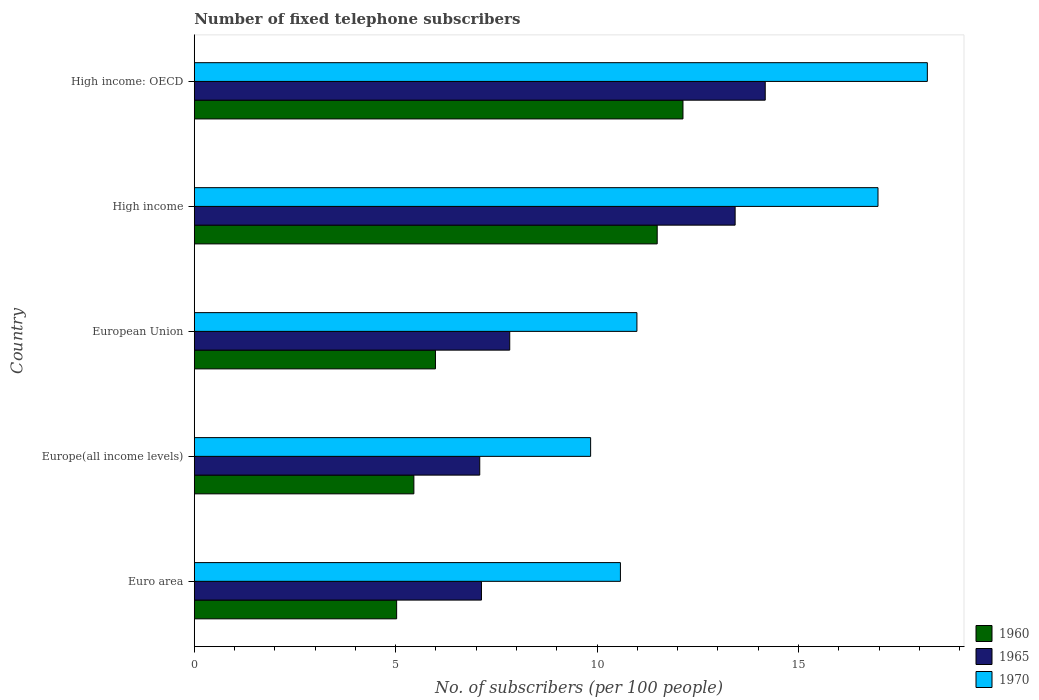How many different coloured bars are there?
Give a very brief answer. 3. How many groups of bars are there?
Your answer should be compact. 5. Are the number of bars per tick equal to the number of legend labels?
Offer a very short reply. Yes. What is the label of the 5th group of bars from the top?
Keep it short and to the point. Euro area. In how many cases, is the number of bars for a given country not equal to the number of legend labels?
Make the answer very short. 0. What is the number of fixed telephone subscribers in 1970 in European Union?
Offer a very short reply. 10.99. Across all countries, what is the maximum number of fixed telephone subscribers in 1970?
Give a very brief answer. 18.2. Across all countries, what is the minimum number of fixed telephone subscribers in 1960?
Your response must be concise. 5.02. In which country was the number of fixed telephone subscribers in 1965 maximum?
Offer a terse response. High income: OECD. In which country was the number of fixed telephone subscribers in 1970 minimum?
Give a very brief answer. Europe(all income levels). What is the total number of fixed telephone subscribers in 1970 in the graph?
Provide a succinct answer. 66.58. What is the difference between the number of fixed telephone subscribers in 1960 in Europe(all income levels) and that in High income?
Provide a short and direct response. -6.04. What is the difference between the number of fixed telephone subscribers in 1970 in European Union and the number of fixed telephone subscribers in 1965 in High income?
Your answer should be compact. -2.44. What is the average number of fixed telephone subscribers in 1965 per country?
Make the answer very short. 9.93. What is the difference between the number of fixed telephone subscribers in 1965 and number of fixed telephone subscribers in 1970 in High income?
Keep it short and to the point. -3.55. What is the ratio of the number of fixed telephone subscribers in 1970 in Euro area to that in High income: OECD?
Give a very brief answer. 0.58. What is the difference between the highest and the second highest number of fixed telephone subscribers in 1970?
Provide a succinct answer. 1.22. What is the difference between the highest and the lowest number of fixed telephone subscribers in 1960?
Your answer should be very brief. 7.11. What does the 3rd bar from the bottom in Euro area represents?
Your answer should be very brief. 1970. Is it the case that in every country, the sum of the number of fixed telephone subscribers in 1965 and number of fixed telephone subscribers in 1960 is greater than the number of fixed telephone subscribers in 1970?
Provide a short and direct response. Yes. How many bars are there?
Make the answer very short. 15. How many countries are there in the graph?
Provide a short and direct response. 5. Are the values on the major ticks of X-axis written in scientific E-notation?
Offer a very short reply. No. How many legend labels are there?
Your answer should be very brief. 3. What is the title of the graph?
Offer a very short reply. Number of fixed telephone subscribers. What is the label or title of the X-axis?
Your response must be concise. No. of subscribers (per 100 people). What is the No. of subscribers (per 100 people) in 1960 in Euro area?
Offer a very short reply. 5.02. What is the No. of subscribers (per 100 people) in 1965 in Euro area?
Your response must be concise. 7.13. What is the No. of subscribers (per 100 people) in 1970 in Euro area?
Provide a short and direct response. 10.58. What is the No. of subscribers (per 100 people) of 1960 in Europe(all income levels)?
Your answer should be compact. 5.45. What is the No. of subscribers (per 100 people) in 1965 in Europe(all income levels)?
Keep it short and to the point. 7.09. What is the No. of subscribers (per 100 people) of 1970 in Europe(all income levels)?
Your answer should be very brief. 9.84. What is the No. of subscribers (per 100 people) in 1960 in European Union?
Keep it short and to the point. 5.99. What is the No. of subscribers (per 100 people) of 1965 in European Union?
Keep it short and to the point. 7.83. What is the No. of subscribers (per 100 people) in 1970 in European Union?
Offer a very short reply. 10.99. What is the No. of subscribers (per 100 people) in 1960 in High income?
Offer a very short reply. 11.49. What is the No. of subscribers (per 100 people) of 1965 in High income?
Make the answer very short. 13.43. What is the No. of subscribers (per 100 people) in 1970 in High income?
Offer a terse response. 16.97. What is the No. of subscribers (per 100 people) of 1960 in High income: OECD?
Offer a very short reply. 12.13. What is the No. of subscribers (per 100 people) in 1965 in High income: OECD?
Provide a short and direct response. 14.17. What is the No. of subscribers (per 100 people) in 1970 in High income: OECD?
Your answer should be compact. 18.2. Across all countries, what is the maximum No. of subscribers (per 100 people) in 1960?
Keep it short and to the point. 12.13. Across all countries, what is the maximum No. of subscribers (per 100 people) in 1965?
Offer a terse response. 14.17. Across all countries, what is the maximum No. of subscribers (per 100 people) in 1970?
Give a very brief answer. 18.2. Across all countries, what is the minimum No. of subscribers (per 100 people) of 1960?
Your answer should be compact. 5.02. Across all countries, what is the minimum No. of subscribers (per 100 people) in 1965?
Make the answer very short. 7.09. Across all countries, what is the minimum No. of subscribers (per 100 people) of 1970?
Ensure brevity in your answer.  9.84. What is the total No. of subscribers (per 100 people) of 1960 in the graph?
Give a very brief answer. 40.08. What is the total No. of subscribers (per 100 people) of 1965 in the graph?
Offer a terse response. 49.65. What is the total No. of subscribers (per 100 people) of 1970 in the graph?
Your answer should be compact. 66.58. What is the difference between the No. of subscribers (per 100 people) of 1960 in Euro area and that in Europe(all income levels)?
Provide a succinct answer. -0.43. What is the difference between the No. of subscribers (per 100 people) in 1965 in Euro area and that in Europe(all income levels)?
Your response must be concise. 0.04. What is the difference between the No. of subscribers (per 100 people) in 1970 in Euro area and that in Europe(all income levels)?
Offer a very short reply. 0.74. What is the difference between the No. of subscribers (per 100 people) of 1960 in Euro area and that in European Union?
Your response must be concise. -0.96. What is the difference between the No. of subscribers (per 100 people) of 1965 in Euro area and that in European Union?
Give a very brief answer. -0.7. What is the difference between the No. of subscribers (per 100 people) of 1970 in Euro area and that in European Union?
Provide a short and direct response. -0.41. What is the difference between the No. of subscribers (per 100 people) in 1960 in Euro area and that in High income?
Ensure brevity in your answer.  -6.47. What is the difference between the No. of subscribers (per 100 people) of 1965 in Euro area and that in High income?
Ensure brevity in your answer.  -6.3. What is the difference between the No. of subscribers (per 100 people) of 1970 in Euro area and that in High income?
Provide a short and direct response. -6.39. What is the difference between the No. of subscribers (per 100 people) in 1960 in Euro area and that in High income: OECD?
Provide a short and direct response. -7.11. What is the difference between the No. of subscribers (per 100 people) of 1965 in Euro area and that in High income: OECD?
Ensure brevity in your answer.  -7.04. What is the difference between the No. of subscribers (per 100 people) in 1970 in Euro area and that in High income: OECD?
Offer a very short reply. -7.62. What is the difference between the No. of subscribers (per 100 people) in 1960 in Europe(all income levels) and that in European Union?
Make the answer very short. -0.54. What is the difference between the No. of subscribers (per 100 people) of 1965 in Europe(all income levels) and that in European Union?
Your response must be concise. -0.74. What is the difference between the No. of subscribers (per 100 people) of 1970 in Europe(all income levels) and that in European Union?
Offer a terse response. -1.15. What is the difference between the No. of subscribers (per 100 people) of 1960 in Europe(all income levels) and that in High income?
Provide a succinct answer. -6.04. What is the difference between the No. of subscribers (per 100 people) in 1965 in Europe(all income levels) and that in High income?
Your answer should be compact. -6.34. What is the difference between the No. of subscribers (per 100 people) in 1970 in Europe(all income levels) and that in High income?
Your answer should be very brief. -7.13. What is the difference between the No. of subscribers (per 100 people) in 1960 in Europe(all income levels) and that in High income: OECD?
Give a very brief answer. -6.68. What is the difference between the No. of subscribers (per 100 people) in 1965 in Europe(all income levels) and that in High income: OECD?
Your answer should be very brief. -7.09. What is the difference between the No. of subscribers (per 100 people) of 1970 in Europe(all income levels) and that in High income: OECD?
Offer a very short reply. -8.36. What is the difference between the No. of subscribers (per 100 people) in 1960 in European Union and that in High income?
Offer a very short reply. -5.5. What is the difference between the No. of subscribers (per 100 people) in 1965 in European Union and that in High income?
Your response must be concise. -5.6. What is the difference between the No. of subscribers (per 100 people) of 1970 in European Union and that in High income?
Keep it short and to the point. -5.98. What is the difference between the No. of subscribers (per 100 people) in 1960 in European Union and that in High income: OECD?
Your answer should be compact. -6.14. What is the difference between the No. of subscribers (per 100 people) in 1965 in European Union and that in High income: OECD?
Ensure brevity in your answer.  -6.34. What is the difference between the No. of subscribers (per 100 people) in 1970 in European Union and that in High income: OECD?
Make the answer very short. -7.21. What is the difference between the No. of subscribers (per 100 people) of 1960 in High income and that in High income: OECD?
Your answer should be compact. -0.64. What is the difference between the No. of subscribers (per 100 people) of 1965 in High income and that in High income: OECD?
Offer a terse response. -0.75. What is the difference between the No. of subscribers (per 100 people) of 1970 in High income and that in High income: OECD?
Provide a short and direct response. -1.22. What is the difference between the No. of subscribers (per 100 people) of 1960 in Euro area and the No. of subscribers (per 100 people) of 1965 in Europe(all income levels)?
Provide a succinct answer. -2.06. What is the difference between the No. of subscribers (per 100 people) of 1960 in Euro area and the No. of subscribers (per 100 people) of 1970 in Europe(all income levels)?
Provide a short and direct response. -4.82. What is the difference between the No. of subscribers (per 100 people) in 1965 in Euro area and the No. of subscribers (per 100 people) in 1970 in Europe(all income levels)?
Your response must be concise. -2.71. What is the difference between the No. of subscribers (per 100 people) in 1960 in Euro area and the No. of subscribers (per 100 people) in 1965 in European Union?
Offer a terse response. -2.81. What is the difference between the No. of subscribers (per 100 people) of 1960 in Euro area and the No. of subscribers (per 100 people) of 1970 in European Union?
Ensure brevity in your answer.  -5.96. What is the difference between the No. of subscribers (per 100 people) of 1965 in Euro area and the No. of subscribers (per 100 people) of 1970 in European Union?
Ensure brevity in your answer.  -3.86. What is the difference between the No. of subscribers (per 100 people) in 1960 in Euro area and the No. of subscribers (per 100 people) in 1965 in High income?
Provide a short and direct response. -8.4. What is the difference between the No. of subscribers (per 100 people) in 1960 in Euro area and the No. of subscribers (per 100 people) in 1970 in High income?
Your response must be concise. -11.95. What is the difference between the No. of subscribers (per 100 people) in 1965 in Euro area and the No. of subscribers (per 100 people) in 1970 in High income?
Ensure brevity in your answer.  -9.84. What is the difference between the No. of subscribers (per 100 people) in 1960 in Euro area and the No. of subscribers (per 100 people) in 1965 in High income: OECD?
Offer a very short reply. -9.15. What is the difference between the No. of subscribers (per 100 people) of 1960 in Euro area and the No. of subscribers (per 100 people) of 1970 in High income: OECD?
Your answer should be very brief. -13.17. What is the difference between the No. of subscribers (per 100 people) of 1965 in Euro area and the No. of subscribers (per 100 people) of 1970 in High income: OECD?
Your answer should be compact. -11.07. What is the difference between the No. of subscribers (per 100 people) in 1960 in Europe(all income levels) and the No. of subscribers (per 100 people) in 1965 in European Union?
Your answer should be very brief. -2.38. What is the difference between the No. of subscribers (per 100 people) of 1960 in Europe(all income levels) and the No. of subscribers (per 100 people) of 1970 in European Union?
Provide a succinct answer. -5.54. What is the difference between the No. of subscribers (per 100 people) in 1965 in Europe(all income levels) and the No. of subscribers (per 100 people) in 1970 in European Union?
Provide a short and direct response. -3.9. What is the difference between the No. of subscribers (per 100 people) in 1960 in Europe(all income levels) and the No. of subscribers (per 100 people) in 1965 in High income?
Provide a succinct answer. -7.97. What is the difference between the No. of subscribers (per 100 people) in 1960 in Europe(all income levels) and the No. of subscribers (per 100 people) in 1970 in High income?
Provide a succinct answer. -11.52. What is the difference between the No. of subscribers (per 100 people) in 1965 in Europe(all income levels) and the No. of subscribers (per 100 people) in 1970 in High income?
Your answer should be very brief. -9.89. What is the difference between the No. of subscribers (per 100 people) of 1960 in Europe(all income levels) and the No. of subscribers (per 100 people) of 1965 in High income: OECD?
Your response must be concise. -8.72. What is the difference between the No. of subscribers (per 100 people) in 1960 in Europe(all income levels) and the No. of subscribers (per 100 people) in 1970 in High income: OECD?
Keep it short and to the point. -12.75. What is the difference between the No. of subscribers (per 100 people) in 1965 in Europe(all income levels) and the No. of subscribers (per 100 people) in 1970 in High income: OECD?
Your response must be concise. -11.11. What is the difference between the No. of subscribers (per 100 people) in 1960 in European Union and the No. of subscribers (per 100 people) in 1965 in High income?
Provide a short and direct response. -7.44. What is the difference between the No. of subscribers (per 100 people) in 1960 in European Union and the No. of subscribers (per 100 people) in 1970 in High income?
Give a very brief answer. -10.99. What is the difference between the No. of subscribers (per 100 people) of 1965 in European Union and the No. of subscribers (per 100 people) of 1970 in High income?
Offer a terse response. -9.14. What is the difference between the No. of subscribers (per 100 people) in 1960 in European Union and the No. of subscribers (per 100 people) in 1965 in High income: OECD?
Your response must be concise. -8.19. What is the difference between the No. of subscribers (per 100 people) in 1960 in European Union and the No. of subscribers (per 100 people) in 1970 in High income: OECD?
Ensure brevity in your answer.  -12.21. What is the difference between the No. of subscribers (per 100 people) in 1965 in European Union and the No. of subscribers (per 100 people) in 1970 in High income: OECD?
Provide a succinct answer. -10.37. What is the difference between the No. of subscribers (per 100 people) of 1960 in High income and the No. of subscribers (per 100 people) of 1965 in High income: OECD?
Offer a very short reply. -2.68. What is the difference between the No. of subscribers (per 100 people) of 1960 in High income and the No. of subscribers (per 100 people) of 1970 in High income: OECD?
Make the answer very short. -6.71. What is the difference between the No. of subscribers (per 100 people) of 1965 in High income and the No. of subscribers (per 100 people) of 1970 in High income: OECD?
Provide a succinct answer. -4.77. What is the average No. of subscribers (per 100 people) of 1960 per country?
Keep it short and to the point. 8.02. What is the average No. of subscribers (per 100 people) in 1965 per country?
Provide a succinct answer. 9.93. What is the average No. of subscribers (per 100 people) in 1970 per country?
Keep it short and to the point. 13.32. What is the difference between the No. of subscribers (per 100 people) of 1960 and No. of subscribers (per 100 people) of 1965 in Euro area?
Keep it short and to the point. -2.11. What is the difference between the No. of subscribers (per 100 people) in 1960 and No. of subscribers (per 100 people) in 1970 in Euro area?
Provide a succinct answer. -5.56. What is the difference between the No. of subscribers (per 100 people) of 1965 and No. of subscribers (per 100 people) of 1970 in Euro area?
Ensure brevity in your answer.  -3.45. What is the difference between the No. of subscribers (per 100 people) of 1960 and No. of subscribers (per 100 people) of 1965 in Europe(all income levels)?
Provide a short and direct response. -1.64. What is the difference between the No. of subscribers (per 100 people) of 1960 and No. of subscribers (per 100 people) of 1970 in Europe(all income levels)?
Provide a short and direct response. -4.39. What is the difference between the No. of subscribers (per 100 people) in 1965 and No. of subscribers (per 100 people) in 1970 in Europe(all income levels)?
Offer a terse response. -2.75. What is the difference between the No. of subscribers (per 100 people) in 1960 and No. of subscribers (per 100 people) in 1965 in European Union?
Make the answer very short. -1.84. What is the difference between the No. of subscribers (per 100 people) of 1960 and No. of subscribers (per 100 people) of 1970 in European Union?
Provide a short and direct response. -5. What is the difference between the No. of subscribers (per 100 people) in 1965 and No. of subscribers (per 100 people) in 1970 in European Union?
Give a very brief answer. -3.16. What is the difference between the No. of subscribers (per 100 people) in 1960 and No. of subscribers (per 100 people) in 1965 in High income?
Give a very brief answer. -1.93. What is the difference between the No. of subscribers (per 100 people) of 1960 and No. of subscribers (per 100 people) of 1970 in High income?
Offer a very short reply. -5.48. What is the difference between the No. of subscribers (per 100 people) of 1965 and No. of subscribers (per 100 people) of 1970 in High income?
Keep it short and to the point. -3.55. What is the difference between the No. of subscribers (per 100 people) of 1960 and No. of subscribers (per 100 people) of 1965 in High income: OECD?
Provide a short and direct response. -2.04. What is the difference between the No. of subscribers (per 100 people) of 1960 and No. of subscribers (per 100 people) of 1970 in High income: OECD?
Make the answer very short. -6.07. What is the difference between the No. of subscribers (per 100 people) in 1965 and No. of subscribers (per 100 people) in 1970 in High income: OECD?
Your answer should be very brief. -4.02. What is the ratio of the No. of subscribers (per 100 people) in 1960 in Euro area to that in Europe(all income levels)?
Offer a terse response. 0.92. What is the ratio of the No. of subscribers (per 100 people) in 1965 in Euro area to that in Europe(all income levels)?
Keep it short and to the point. 1.01. What is the ratio of the No. of subscribers (per 100 people) of 1970 in Euro area to that in Europe(all income levels)?
Keep it short and to the point. 1.08. What is the ratio of the No. of subscribers (per 100 people) in 1960 in Euro area to that in European Union?
Ensure brevity in your answer.  0.84. What is the ratio of the No. of subscribers (per 100 people) of 1965 in Euro area to that in European Union?
Offer a terse response. 0.91. What is the ratio of the No. of subscribers (per 100 people) of 1970 in Euro area to that in European Union?
Provide a short and direct response. 0.96. What is the ratio of the No. of subscribers (per 100 people) in 1960 in Euro area to that in High income?
Provide a short and direct response. 0.44. What is the ratio of the No. of subscribers (per 100 people) of 1965 in Euro area to that in High income?
Your answer should be compact. 0.53. What is the ratio of the No. of subscribers (per 100 people) of 1970 in Euro area to that in High income?
Give a very brief answer. 0.62. What is the ratio of the No. of subscribers (per 100 people) of 1960 in Euro area to that in High income: OECD?
Offer a very short reply. 0.41. What is the ratio of the No. of subscribers (per 100 people) of 1965 in Euro area to that in High income: OECD?
Make the answer very short. 0.5. What is the ratio of the No. of subscribers (per 100 people) in 1970 in Euro area to that in High income: OECD?
Make the answer very short. 0.58. What is the ratio of the No. of subscribers (per 100 people) in 1960 in Europe(all income levels) to that in European Union?
Give a very brief answer. 0.91. What is the ratio of the No. of subscribers (per 100 people) of 1965 in Europe(all income levels) to that in European Union?
Your response must be concise. 0.91. What is the ratio of the No. of subscribers (per 100 people) in 1970 in Europe(all income levels) to that in European Union?
Make the answer very short. 0.9. What is the ratio of the No. of subscribers (per 100 people) in 1960 in Europe(all income levels) to that in High income?
Provide a short and direct response. 0.47. What is the ratio of the No. of subscribers (per 100 people) in 1965 in Europe(all income levels) to that in High income?
Give a very brief answer. 0.53. What is the ratio of the No. of subscribers (per 100 people) of 1970 in Europe(all income levels) to that in High income?
Ensure brevity in your answer.  0.58. What is the ratio of the No. of subscribers (per 100 people) of 1960 in Europe(all income levels) to that in High income: OECD?
Your answer should be compact. 0.45. What is the ratio of the No. of subscribers (per 100 people) in 1970 in Europe(all income levels) to that in High income: OECD?
Your answer should be very brief. 0.54. What is the ratio of the No. of subscribers (per 100 people) of 1960 in European Union to that in High income?
Provide a short and direct response. 0.52. What is the ratio of the No. of subscribers (per 100 people) of 1965 in European Union to that in High income?
Your answer should be very brief. 0.58. What is the ratio of the No. of subscribers (per 100 people) of 1970 in European Union to that in High income?
Your answer should be very brief. 0.65. What is the ratio of the No. of subscribers (per 100 people) in 1960 in European Union to that in High income: OECD?
Provide a short and direct response. 0.49. What is the ratio of the No. of subscribers (per 100 people) of 1965 in European Union to that in High income: OECD?
Offer a terse response. 0.55. What is the ratio of the No. of subscribers (per 100 people) in 1970 in European Union to that in High income: OECD?
Provide a short and direct response. 0.6. What is the ratio of the No. of subscribers (per 100 people) in 1960 in High income to that in High income: OECD?
Provide a short and direct response. 0.95. What is the ratio of the No. of subscribers (per 100 people) in 1965 in High income to that in High income: OECD?
Your response must be concise. 0.95. What is the ratio of the No. of subscribers (per 100 people) of 1970 in High income to that in High income: OECD?
Provide a succinct answer. 0.93. What is the difference between the highest and the second highest No. of subscribers (per 100 people) of 1960?
Provide a short and direct response. 0.64. What is the difference between the highest and the second highest No. of subscribers (per 100 people) of 1965?
Offer a very short reply. 0.75. What is the difference between the highest and the second highest No. of subscribers (per 100 people) in 1970?
Keep it short and to the point. 1.22. What is the difference between the highest and the lowest No. of subscribers (per 100 people) of 1960?
Your response must be concise. 7.11. What is the difference between the highest and the lowest No. of subscribers (per 100 people) in 1965?
Your answer should be compact. 7.09. What is the difference between the highest and the lowest No. of subscribers (per 100 people) of 1970?
Give a very brief answer. 8.36. 